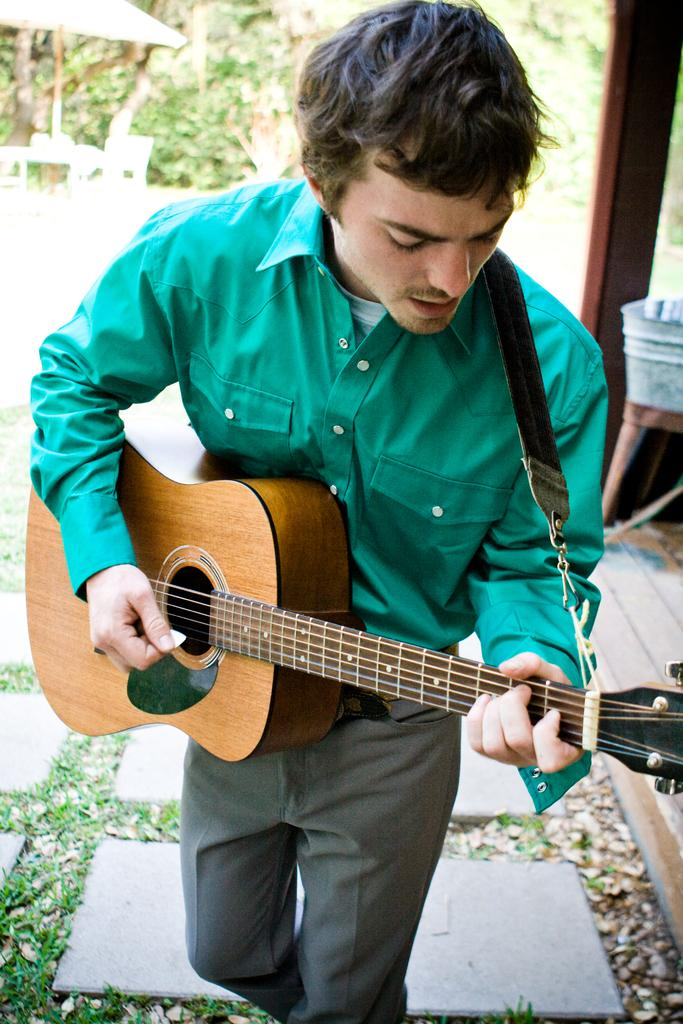What is the main subject of the image? There is a person in the image. What is the person doing in the image? The person is standing and playing a guitar. What can be seen in the background of the image? There are trees in the background of the image. Can you see any goats in the image? There are no goats present in the image. What type of railway can be seen in the image? There is no railway present in the image. 